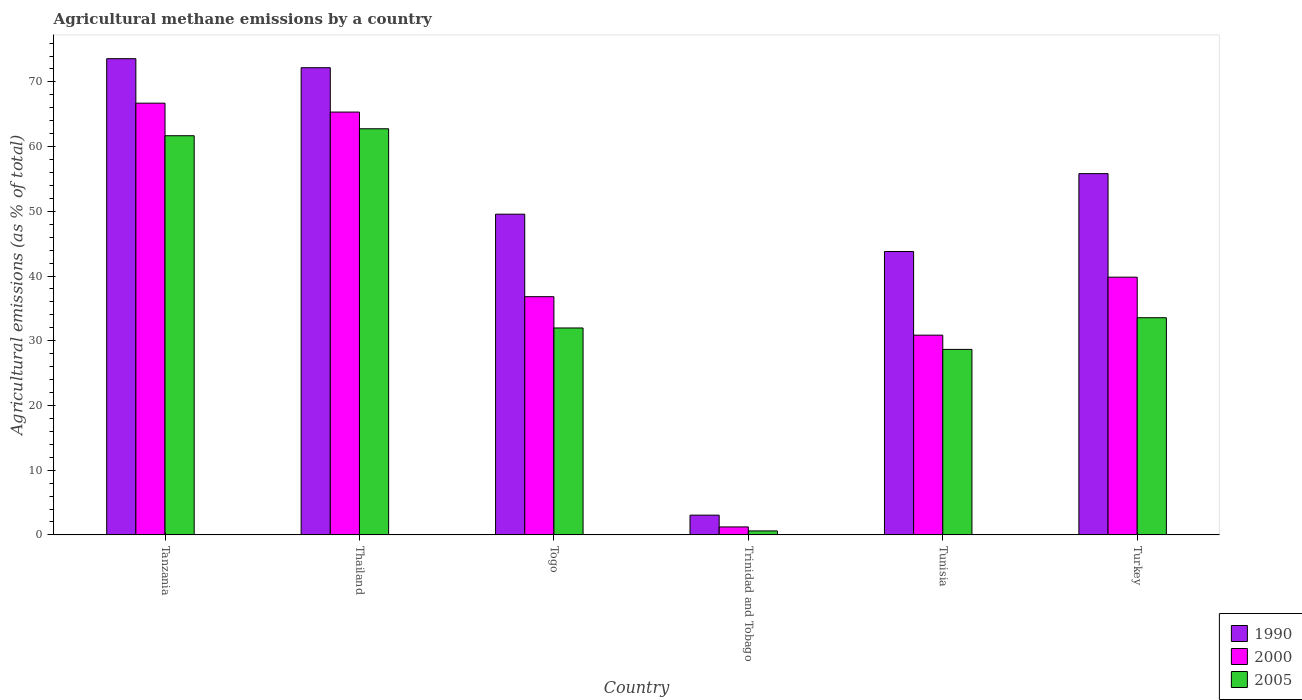How many different coloured bars are there?
Your response must be concise. 3. How many groups of bars are there?
Ensure brevity in your answer.  6. Are the number of bars on each tick of the X-axis equal?
Keep it short and to the point. Yes. What is the label of the 3rd group of bars from the left?
Your answer should be very brief. Togo. In how many cases, is the number of bars for a given country not equal to the number of legend labels?
Offer a very short reply. 0. What is the amount of agricultural methane emitted in 2005 in Turkey?
Provide a succinct answer. 33.56. Across all countries, what is the maximum amount of agricultural methane emitted in 2000?
Your answer should be compact. 66.72. Across all countries, what is the minimum amount of agricultural methane emitted in 1990?
Your response must be concise. 3.05. In which country was the amount of agricultural methane emitted in 1990 maximum?
Provide a short and direct response. Tanzania. In which country was the amount of agricultural methane emitted in 1990 minimum?
Provide a succinct answer. Trinidad and Tobago. What is the total amount of agricultural methane emitted in 2000 in the graph?
Make the answer very short. 240.79. What is the difference between the amount of agricultural methane emitted in 2005 in Tunisia and that in Turkey?
Provide a succinct answer. -4.9. What is the difference between the amount of agricultural methane emitted in 2000 in Tunisia and the amount of agricultural methane emitted in 1990 in Trinidad and Tobago?
Provide a succinct answer. 27.81. What is the average amount of agricultural methane emitted in 1990 per country?
Keep it short and to the point. 49.67. What is the difference between the amount of agricultural methane emitted of/in 1990 and amount of agricultural methane emitted of/in 2005 in Togo?
Ensure brevity in your answer.  17.58. In how many countries, is the amount of agricultural methane emitted in 1990 greater than 42 %?
Give a very brief answer. 5. What is the ratio of the amount of agricultural methane emitted in 2005 in Tanzania to that in Togo?
Your answer should be very brief. 1.93. What is the difference between the highest and the second highest amount of agricultural methane emitted in 2005?
Your response must be concise. -28.12. What is the difference between the highest and the lowest amount of agricultural methane emitted in 2000?
Ensure brevity in your answer.  65.49. In how many countries, is the amount of agricultural methane emitted in 2000 greater than the average amount of agricultural methane emitted in 2000 taken over all countries?
Your answer should be compact. 2. What does the 3rd bar from the left in Tunisia represents?
Offer a terse response. 2005. Is it the case that in every country, the sum of the amount of agricultural methane emitted in 1990 and amount of agricultural methane emitted in 2005 is greater than the amount of agricultural methane emitted in 2000?
Your response must be concise. Yes. How many bars are there?
Your answer should be compact. 18. What is the difference between two consecutive major ticks on the Y-axis?
Ensure brevity in your answer.  10. Are the values on the major ticks of Y-axis written in scientific E-notation?
Your response must be concise. No. Does the graph contain any zero values?
Your answer should be compact. No. Where does the legend appear in the graph?
Your answer should be compact. Bottom right. How are the legend labels stacked?
Provide a succinct answer. Vertical. What is the title of the graph?
Ensure brevity in your answer.  Agricultural methane emissions by a country. What is the label or title of the Y-axis?
Make the answer very short. Agricultural emissions (as % of total). What is the Agricultural emissions (as % of total) in 1990 in Tanzania?
Ensure brevity in your answer.  73.59. What is the Agricultural emissions (as % of total) in 2000 in Tanzania?
Offer a terse response. 66.72. What is the Agricultural emissions (as % of total) in 2005 in Tanzania?
Offer a very short reply. 61.68. What is the Agricultural emissions (as % of total) of 1990 in Thailand?
Provide a short and direct response. 72.19. What is the Agricultural emissions (as % of total) of 2000 in Thailand?
Your answer should be very brief. 65.34. What is the Agricultural emissions (as % of total) of 2005 in Thailand?
Make the answer very short. 62.76. What is the Agricultural emissions (as % of total) of 1990 in Togo?
Offer a terse response. 49.56. What is the Agricultural emissions (as % of total) in 2000 in Togo?
Offer a very short reply. 36.81. What is the Agricultural emissions (as % of total) of 2005 in Togo?
Provide a succinct answer. 31.98. What is the Agricultural emissions (as % of total) of 1990 in Trinidad and Tobago?
Your answer should be compact. 3.05. What is the Agricultural emissions (as % of total) in 2000 in Trinidad and Tobago?
Make the answer very short. 1.23. What is the Agricultural emissions (as % of total) of 2005 in Trinidad and Tobago?
Ensure brevity in your answer.  0.62. What is the Agricultural emissions (as % of total) in 1990 in Tunisia?
Make the answer very short. 43.79. What is the Agricultural emissions (as % of total) of 2000 in Tunisia?
Provide a succinct answer. 30.87. What is the Agricultural emissions (as % of total) in 2005 in Tunisia?
Ensure brevity in your answer.  28.66. What is the Agricultural emissions (as % of total) of 1990 in Turkey?
Offer a terse response. 55.83. What is the Agricultural emissions (as % of total) of 2000 in Turkey?
Give a very brief answer. 39.83. What is the Agricultural emissions (as % of total) in 2005 in Turkey?
Your answer should be very brief. 33.56. Across all countries, what is the maximum Agricultural emissions (as % of total) of 1990?
Provide a short and direct response. 73.59. Across all countries, what is the maximum Agricultural emissions (as % of total) of 2000?
Your answer should be very brief. 66.72. Across all countries, what is the maximum Agricultural emissions (as % of total) of 2005?
Your response must be concise. 62.76. Across all countries, what is the minimum Agricultural emissions (as % of total) of 1990?
Offer a terse response. 3.05. Across all countries, what is the minimum Agricultural emissions (as % of total) of 2000?
Ensure brevity in your answer.  1.23. Across all countries, what is the minimum Agricultural emissions (as % of total) of 2005?
Give a very brief answer. 0.62. What is the total Agricultural emissions (as % of total) of 1990 in the graph?
Ensure brevity in your answer.  298.01. What is the total Agricultural emissions (as % of total) of 2000 in the graph?
Your answer should be compact. 240.79. What is the total Agricultural emissions (as % of total) of 2005 in the graph?
Provide a short and direct response. 219.26. What is the difference between the Agricultural emissions (as % of total) of 1990 in Tanzania and that in Thailand?
Ensure brevity in your answer.  1.39. What is the difference between the Agricultural emissions (as % of total) of 2000 in Tanzania and that in Thailand?
Make the answer very short. 1.38. What is the difference between the Agricultural emissions (as % of total) in 2005 in Tanzania and that in Thailand?
Provide a short and direct response. -1.08. What is the difference between the Agricultural emissions (as % of total) in 1990 in Tanzania and that in Togo?
Your answer should be compact. 24.03. What is the difference between the Agricultural emissions (as % of total) of 2000 in Tanzania and that in Togo?
Make the answer very short. 29.9. What is the difference between the Agricultural emissions (as % of total) in 2005 in Tanzania and that in Togo?
Offer a terse response. 29.71. What is the difference between the Agricultural emissions (as % of total) in 1990 in Tanzania and that in Trinidad and Tobago?
Make the answer very short. 70.54. What is the difference between the Agricultural emissions (as % of total) of 2000 in Tanzania and that in Trinidad and Tobago?
Make the answer very short. 65.49. What is the difference between the Agricultural emissions (as % of total) in 2005 in Tanzania and that in Trinidad and Tobago?
Give a very brief answer. 61.07. What is the difference between the Agricultural emissions (as % of total) in 1990 in Tanzania and that in Tunisia?
Offer a very short reply. 29.8. What is the difference between the Agricultural emissions (as % of total) in 2000 in Tanzania and that in Tunisia?
Your response must be concise. 35.85. What is the difference between the Agricultural emissions (as % of total) of 2005 in Tanzania and that in Tunisia?
Your answer should be compact. 33.02. What is the difference between the Agricultural emissions (as % of total) in 1990 in Tanzania and that in Turkey?
Give a very brief answer. 17.76. What is the difference between the Agricultural emissions (as % of total) of 2000 in Tanzania and that in Turkey?
Your answer should be compact. 26.89. What is the difference between the Agricultural emissions (as % of total) of 2005 in Tanzania and that in Turkey?
Ensure brevity in your answer.  28.12. What is the difference between the Agricultural emissions (as % of total) of 1990 in Thailand and that in Togo?
Ensure brevity in your answer.  22.63. What is the difference between the Agricultural emissions (as % of total) in 2000 in Thailand and that in Togo?
Your answer should be very brief. 28.53. What is the difference between the Agricultural emissions (as % of total) of 2005 in Thailand and that in Togo?
Make the answer very short. 30.78. What is the difference between the Agricultural emissions (as % of total) in 1990 in Thailand and that in Trinidad and Tobago?
Make the answer very short. 69.14. What is the difference between the Agricultural emissions (as % of total) of 2000 in Thailand and that in Trinidad and Tobago?
Your response must be concise. 64.11. What is the difference between the Agricultural emissions (as % of total) in 2005 in Thailand and that in Trinidad and Tobago?
Offer a very short reply. 62.14. What is the difference between the Agricultural emissions (as % of total) in 1990 in Thailand and that in Tunisia?
Make the answer very short. 28.4. What is the difference between the Agricultural emissions (as % of total) of 2000 in Thailand and that in Tunisia?
Your response must be concise. 34.47. What is the difference between the Agricultural emissions (as % of total) of 2005 in Thailand and that in Tunisia?
Give a very brief answer. 34.09. What is the difference between the Agricultural emissions (as % of total) of 1990 in Thailand and that in Turkey?
Offer a very short reply. 16.37. What is the difference between the Agricultural emissions (as % of total) of 2000 in Thailand and that in Turkey?
Offer a terse response. 25.51. What is the difference between the Agricultural emissions (as % of total) in 2005 in Thailand and that in Turkey?
Give a very brief answer. 29.2. What is the difference between the Agricultural emissions (as % of total) of 1990 in Togo and that in Trinidad and Tobago?
Your answer should be compact. 46.51. What is the difference between the Agricultural emissions (as % of total) in 2000 in Togo and that in Trinidad and Tobago?
Ensure brevity in your answer.  35.58. What is the difference between the Agricultural emissions (as % of total) of 2005 in Togo and that in Trinidad and Tobago?
Offer a terse response. 31.36. What is the difference between the Agricultural emissions (as % of total) of 1990 in Togo and that in Tunisia?
Make the answer very short. 5.77. What is the difference between the Agricultural emissions (as % of total) in 2000 in Togo and that in Tunisia?
Ensure brevity in your answer.  5.95. What is the difference between the Agricultural emissions (as % of total) in 2005 in Togo and that in Tunisia?
Make the answer very short. 3.31. What is the difference between the Agricultural emissions (as % of total) in 1990 in Togo and that in Turkey?
Your answer should be very brief. -6.27. What is the difference between the Agricultural emissions (as % of total) in 2000 in Togo and that in Turkey?
Your answer should be compact. -3.01. What is the difference between the Agricultural emissions (as % of total) in 2005 in Togo and that in Turkey?
Ensure brevity in your answer.  -1.58. What is the difference between the Agricultural emissions (as % of total) in 1990 in Trinidad and Tobago and that in Tunisia?
Keep it short and to the point. -40.74. What is the difference between the Agricultural emissions (as % of total) of 2000 in Trinidad and Tobago and that in Tunisia?
Give a very brief answer. -29.64. What is the difference between the Agricultural emissions (as % of total) in 2005 in Trinidad and Tobago and that in Tunisia?
Your answer should be very brief. -28.05. What is the difference between the Agricultural emissions (as % of total) of 1990 in Trinidad and Tobago and that in Turkey?
Ensure brevity in your answer.  -52.78. What is the difference between the Agricultural emissions (as % of total) in 2000 in Trinidad and Tobago and that in Turkey?
Keep it short and to the point. -38.6. What is the difference between the Agricultural emissions (as % of total) of 2005 in Trinidad and Tobago and that in Turkey?
Offer a terse response. -32.94. What is the difference between the Agricultural emissions (as % of total) of 1990 in Tunisia and that in Turkey?
Offer a terse response. -12.03. What is the difference between the Agricultural emissions (as % of total) in 2000 in Tunisia and that in Turkey?
Make the answer very short. -8.96. What is the difference between the Agricultural emissions (as % of total) of 2005 in Tunisia and that in Turkey?
Your answer should be very brief. -4.9. What is the difference between the Agricultural emissions (as % of total) in 1990 in Tanzania and the Agricultural emissions (as % of total) in 2000 in Thailand?
Give a very brief answer. 8.25. What is the difference between the Agricultural emissions (as % of total) of 1990 in Tanzania and the Agricultural emissions (as % of total) of 2005 in Thailand?
Provide a succinct answer. 10.83. What is the difference between the Agricultural emissions (as % of total) of 2000 in Tanzania and the Agricultural emissions (as % of total) of 2005 in Thailand?
Offer a terse response. 3.96. What is the difference between the Agricultural emissions (as % of total) in 1990 in Tanzania and the Agricultural emissions (as % of total) in 2000 in Togo?
Your answer should be very brief. 36.78. What is the difference between the Agricultural emissions (as % of total) of 1990 in Tanzania and the Agricultural emissions (as % of total) of 2005 in Togo?
Offer a very short reply. 41.61. What is the difference between the Agricultural emissions (as % of total) of 2000 in Tanzania and the Agricultural emissions (as % of total) of 2005 in Togo?
Your answer should be compact. 34.74. What is the difference between the Agricultural emissions (as % of total) in 1990 in Tanzania and the Agricultural emissions (as % of total) in 2000 in Trinidad and Tobago?
Your answer should be compact. 72.36. What is the difference between the Agricultural emissions (as % of total) in 1990 in Tanzania and the Agricultural emissions (as % of total) in 2005 in Trinidad and Tobago?
Your response must be concise. 72.97. What is the difference between the Agricultural emissions (as % of total) in 2000 in Tanzania and the Agricultural emissions (as % of total) in 2005 in Trinidad and Tobago?
Give a very brief answer. 66.1. What is the difference between the Agricultural emissions (as % of total) of 1990 in Tanzania and the Agricultural emissions (as % of total) of 2000 in Tunisia?
Your answer should be compact. 42.72. What is the difference between the Agricultural emissions (as % of total) of 1990 in Tanzania and the Agricultural emissions (as % of total) of 2005 in Tunisia?
Give a very brief answer. 44.93. What is the difference between the Agricultural emissions (as % of total) in 2000 in Tanzania and the Agricultural emissions (as % of total) in 2005 in Tunisia?
Your answer should be compact. 38.05. What is the difference between the Agricultural emissions (as % of total) of 1990 in Tanzania and the Agricultural emissions (as % of total) of 2000 in Turkey?
Your answer should be compact. 33.76. What is the difference between the Agricultural emissions (as % of total) of 1990 in Tanzania and the Agricultural emissions (as % of total) of 2005 in Turkey?
Your answer should be very brief. 40.03. What is the difference between the Agricultural emissions (as % of total) in 2000 in Tanzania and the Agricultural emissions (as % of total) in 2005 in Turkey?
Give a very brief answer. 33.16. What is the difference between the Agricultural emissions (as % of total) of 1990 in Thailand and the Agricultural emissions (as % of total) of 2000 in Togo?
Provide a short and direct response. 35.38. What is the difference between the Agricultural emissions (as % of total) of 1990 in Thailand and the Agricultural emissions (as % of total) of 2005 in Togo?
Make the answer very short. 40.22. What is the difference between the Agricultural emissions (as % of total) in 2000 in Thailand and the Agricultural emissions (as % of total) in 2005 in Togo?
Ensure brevity in your answer.  33.36. What is the difference between the Agricultural emissions (as % of total) of 1990 in Thailand and the Agricultural emissions (as % of total) of 2000 in Trinidad and Tobago?
Ensure brevity in your answer.  70.96. What is the difference between the Agricultural emissions (as % of total) in 1990 in Thailand and the Agricultural emissions (as % of total) in 2005 in Trinidad and Tobago?
Offer a terse response. 71.58. What is the difference between the Agricultural emissions (as % of total) of 2000 in Thailand and the Agricultural emissions (as % of total) of 2005 in Trinidad and Tobago?
Offer a very short reply. 64.72. What is the difference between the Agricultural emissions (as % of total) of 1990 in Thailand and the Agricultural emissions (as % of total) of 2000 in Tunisia?
Your answer should be very brief. 41.33. What is the difference between the Agricultural emissions (as % of total) in 1990 in Thailand and the Agricultural emissions (as % of total) in 2005 in Tunisia?
Your response must be concise. 43.53. What is the difference between the Agricultural emissions (as % of total) of 2000 in Thailand and the Agricultural emissions (as % of total) of 2005 in Tunisia?
Ensure brevity in your answer.  36.68. What is the difference between the Agricultural emissions (as % of total) in 1990 in Thailand and the Agricultural emissions (as % of total) in 2000 in Turkey?
Keep it short and to the point. 32.37. What is the difference between the Agricultural emissions (as % of total) in 1990 in Thailand and the Agricultural emissions (as % of total) in 2005 in Turkey?
Your response must be concise. 38.64. What is the difference between the Agricultural emissions (as % of total) of 2000 in Thailand and the Agricultural emissions (as % of total) of 2005 in Turkey?
Keep it short and to the point. 31.78. What is the difference between the Agricultural emissions (as % of total) in 1990 in Togo and the Agricultural emissions (as % of total) in 2000 in Trinidad and Tobago?
Give a very brief answer. 48.33. What is the difference between the Agricultural emissions (as % of total) of 1990 in Togo and the Agricultural emissions (as % of total) of 2005 in Trinidad and Tobago?
Keep it short and to the point. 48.94. What is the difference between the Agricultural emissions (as % of total) in 2000 in Togo and the Agricultural emissions (as % of total) in 2005 in Trinidad and Tobago?
Keep it short and to the point. 36.2. What is the difference between the Agricultural emissions (as % of total) in 1990 in Togo and the Agricultural emissions (as % of total) in 2000 in Tunisia?
Your answer should be compact. 18.69. What is the difference between the Agricultural emissions (as % of total) of 1990 in Togo and the Agricultural emissions (as % of total) of 2005 in Tunisia?
Give a very brief answer. 20.9. What is the difference between the Agricultural emissions (as % of total) of 2000 in Togo and the Agricultural emissions (as % of total) of 2005 in Tunisia?
Your answer should be compact. 8.15. What is the difference between the Agricultural emissions (as % of total) in 1990 in Togo and the Agricultural emissions (as % of total) in 2000 in Turkey?
Keep it short and to the point. 9.73. What is the difference between the Agricultural emissions (as % of total) of 1990 in Togo and the Agricultural emissions (as % of total) of 2005 in Turkey?
Your response must be concise. 16. What is the difference between the Agricultural emissions (as % of total) in 2000 in Togo and the Agricultural emissions (as % of total) in 2005 in Turkey?
Offer a very short reply. 3.25. What is the difference between the Agricultural emissions (as % of total) in 1990 in Trinidad and Tobago and the Agricultural emissions (as % of total) in 2000 in Tunisia?
Keep it short and to the point. -27.81. What is the difference between the Agricultural emissions (as % of total) in 1990 in Trinidad and Tobago and the Agricultural emissions (as % of total) in 2005 in Tunisia?
Keep it short and to the point. -25.61. What is the difference between the Agricultural emissions (as % of total) of 2000 in Trinidad and Tobago and the Agricultural emissions (as % of total) of 2005 in Tunisia?
Ensure brevity in your answer.  -27.43. What is the difference between the Agricultural emissions (as % of total) of 1990 in Trinidad and Tobago and the Agricultural emissions (as % of total) of 2000 in Turkey?
Provide a succinct answer. -36.78. What is the difference between the Agricultural emissions (as % of total) of 1990 in Trinidad and Tobago and the Agricultural emissions (as % of total) of 2005 in Turkey?
Your answer should be compact. -30.51. What is the difference between the Agricultural emissions (as % of total) in 2000 in Trinidad and Tobago and the Agricultural emissions (as % of total) in 2005 in Turkey?
Offer a very short reply. -32.33. What is the difference between the Agricultural emissions (as % of total) of 1990 in Tunisia and the Agricultural emissions (as % of total) of 2000 in Turkey?
Offer a terse response. 3.97. What is the difference between the Agricultural emissions (as % of total) of 1990 in Tunisia and the Agricultural emissions (as % of total) of 2005 in Turkey?
Provide a short and direct response. 10.23. What is the difference between the Agricultural emissions (as % of total) in 2000 in Tunisia and the Agricultural emissions (as % of total) in 2005 in Turkey?
Your response must be concise. -2.69. What is the average Agricultural emissions (as % of total) in 1990 per country?
Keep it short and to the point. 49.67. What is the average Agricultural emissions (as % of total) of 2000 per country?
Ensure brevity in your answer.  40.13. What is the average Agricultural emissions (as % of total) of 2005 per country?
Offer a terse response. 36.54. What is the difference between the Agricultural emissions (as % of total) of 1990 and Agricultural emissions (as % of total) of 2000 in Tanzania?
Your answer should be compact. 6.87. What is the difference between the Agricultural emissions (as % of total) in 1990 and Agricultural emissions (as % of total) in 2005 in Tanzania?
Offer a terse response. 11.91. What is the difference between the Agricultural emissions (as % of total) of 2000 and Agricultural emissions (as % of total) of 2005 in Tanzania?
Offer a terse response. 5.03. What is the difference between the Agricultural emissions (as % of total) of 1990 and Agricultural emissions (as % of total) of 2000 in Thailand?
Ensure brevity in your answer.  6.85. What is the difference between the Agricultural emissions (as % of total) of 1990 and Agricultural emissions (as % of total) of 2005 in Thailand?
Your answer should be very brief. 9.44. What is the difference between the Agricultural emissions (as % of total) in 2000 and Agricultural emissions (as % of total) in 2005 in Thailand?
Provide a short and direct response. 2.58. What is the difference between the Agricultural emissions (as % of total) of 1990 and Agricultural emissions (as % of total) of 2000 in Togo?
Offer a terse response. 12.75. What is the difference between the Agricultural emissions (as % of total) in 1990 and Agricultural emissions (as % of total) in 2005 in Togo?
Keep it short and to the point. 17.58. What is the difference between the Agricultural emissions (as % of total) of 2000 and Agricultural emissions (as % of total) of 2005 in Togo?
Offer a terse response. 4.84. What is the difference between the Agricultural emissions (as % of total) of 1990 and Agricultural emissions (as % of total) of 2000 in Trinidad and Tobago?
Offer a very short reply. 1.82. What is the difference between the Agricultural emissions (as % of total) of 1990 and Agricultural emissions (as % of total) of 2005 in Trinidad and Tobago?
Keep it short and to the point. 2.44. What is the difference between the Agricultural emissions (as % of total) of 2000 and Agricultural emissions (as % of total) of 2005 in Trinidad and Tobago?
Ensure brevity in your answer.  0.61. What is the difference between the Agricultural emissions (as % of total) of 1990 and Agricultural emissions (as % of total) of 2000 in Tunisia?
Your response must be concise. 12.93. What is the difference between the Agricultural emissions (as % of total) in 1990 and Agricultural emissions (as % of total) in 2005 in Tunisia?
Your response must be concise. 15.13. What is the difference between the Agricultural emissions (as % of total) of 2000 and Agricultural emissions (as % of total) of 2005 in Tunisia?
Your answer should be very brief. 2.2. What is the difference between the Agricultural emissions (as % of total) of 1990 and Agricultural emissions (as % of total) of 2000 in Turkey?
Your answer should be compact. 16. What is the difference between the Agricultural emissions (as % of total) in 1990 and Agricultural emissions (as % of total) in 2005 in Turkey?
Your answer should be very brief. 22.27. What is the difference between the Agricultural emissions (as % of total) of 2000 and Agricultural emissions (as % of total) of 2005 in Turkey?
Give a very brief answer. 6.27. What is the ratio of the Agricultural emissions (as % of total) of 1990 in Tanzania to that in Thailand?
Ensure brevity in your answer.  1.02. What is the ratio of the Agricultural emissions (as % of total) in 2000 in Tanzania to that in Thailand?
Make the answer very short. 1.02. What is the ratio of the Agricultural emissions (as % of total) of 2005 in Tanzania to that in Thailand?
Offer a very short reply. 0.98. What is the ratio of the Agricultural emissions (as % of total) of 1990 in Tanzania to that in Togo?
Keep it short and to the point. 1.48. What is the ratio of the Agricultural emissions (as % of total) of 2000 in Tanzania to that in Togo?
Provide a short and direct response. 1.81. What is the ratio of the Agricultural emissions (as % of total) in 2005 in Tanzania to that in Togo?
Ensure brevity in your answer.  1.93. What is the ratio of the Agricultural emissions (as % of total) of 1990 in Tanzania to that in Trinidad and Tobago?
Your response must be concise. 24.11. What is the ratio of the Agricultural emissions (as % of total) in 2000 in Tanzania to that in Trinidad and Tobago?
Your response must be concise. 54.23. What is the ratio of the Agricultural emissions (as % of total) in 2005 in Tanzania to that in Trinidad and Tobago?
Give a very brief answer. 100.13. What is the ratio of the Agricultural emissions (as % of total) in 1990 in Tanzania to that in Tunisia?
Ensure brevity in your answer.  1.68. What is the ratio of the Agricultural emissions (as % of total) in 2000 in Tanzania to that in Tunisia?
Your answer should be very brief. 2.16. What is the ratio of the Agricultural emissions (as % of total) in 2005 in Tanzania to that in Tunisia?
Give a very brief answer. 2.15. What is the ratio of the Agricultural emissions (as % of total) in 1990 in Tanzania to that in Turkey?
Your response must be concise. 1.32. What is the ratio of the Agricultural emissions (as % of total) in 2000 in Tanzania to that in Turkey?
Give a very brief answer. 1.68. What is the ratio of the Agricultural emissions (as % of total) of 2005 in Tanzania to that in Turkey?
Provide a succinct answer. 1.84. What is the ratio of the Agricultural emissions (as % of total) in 1990 in Thailand to that in Togo?
Provide a short and direct response. 1.46. What is the ratio of the Agricultural emissions (as % of total) in 2000 in Thailand to that in Togo?
Offer a terse response. 1.77. What is the ratio of the Agricultural emissions (as % of total) in 2005 in Thailand to that in Togo?
Your answer should be compact. 1.96. What is the ratio of the Agricultural emissions (as % of total) of 1990 in Thailand to that in Trinidad and Tobago?
Offer a terse response. 23.66. What is the ratio of the Agricultural emissions (as % of total) of 2000 in Thailand to that in Trinidad and Tobago?
Your answer should be very brief. 53.11. What is the ratio of the Agricultural emissions (as % of total) of 2005 in Thailand to that in Trinidad and Tobago?
Give a very brief answer. 101.88. What is the ratio of the Agricultural emissions (as % of total) of 1990 in Thailand to that in Tunisia?
Your answer should be compact. 1.65. What is the ratio of the Agricultural emissions (as % of total) in 2000 in Thailand to that in Tunisia?
Your response must be concise. 2.12. What is the ratio of the Agricultural emissions (as % of total) of 2005 in Thailand to that in Tunisia?
Your answer should be very brief. 2.19. What is the ratio of the Agricultural emissions (as % of total) in 1990 in Thailand to that in Turkey?
Offer a very short reply. 1.29. What is the ratio of the Agricultural emissions (as % of total) of 2000 in Thailand to that in Turkey?
Offer a terse response. 1.64. What is the ratio of the Agricultural emissions (as % of total) of 2005 in Thailand to that in Turkey?
Offer a terse response. 1.87. What is the ratio of the Agricultural emissions (as % of total) of 1990 in Togo to that in Trinidad and Tobago?
Ensure brevity in your answer.  16.24. What is the ratio of the Agricultural emissions (as % of total) in 2000 in Togo to that in Trinidad and Tobago?
Make the answer very short. 29.92. What is the ratio of the Agricultural emissions (as % of total) of 2005 in Togo to that in Trinidad and Tobago?
Give a very brief answer. 51.91. What is the ratio of the Agricultural emissions (as % of total) in 1990 in Togo to that in Tunisia?
Ensure brevity in your answer.  1.13. What is the ratio of the Agricultural emissions (as % of total) of 2000 in Togo to that in Tunisia?
Your response must be concise. 1.19. What is the ratio of the Agricultural emissions (as % of total) in 2005 in Togo to that in Tunisia?
Ensure brevity in your answer.  1.12. What is the ratio of the Agricultural emissions (as % of total) of 1990 in Togo to that in Turkey?
Keep it short and to the point. 0.89. What is the ratio of the Agricultural emissions (as % of total) of 2000 in Togo to that in Turkey?
Make the answer very short. 0.92. What is the ratio of the Agricultural emissions (as % of total) in 2005 in Togo to that in Turkey?
Give a very brief answer. 0.95. What is the ratio of the Agricultural emissions (as % of total) of 1990 in Trinidad and Tobago to that in Tunisia?
Ensure brevity in your answer.  0.07. What is the ratio of the Agricultural emissions (as % of total) of 2000 in Trinidad and Tobago to that in Tunisia?
Keep it short and to the point. 0.04. What is the ratio of the Agricultural emissions (as % of total) in 2005 in Trinidad and Tobago to that in Tunisia?
Your response must be concise. 0.02. What is the ratio of the Agricultural emissions (as % of total) of 1990 in Trinidad and Tobago to that in Turkey?
Your response must be concise. 0.05. What is the ratio of the Agricultural emissions (as % of total) in 2000 in Trinidad and Tobago to that in Turkey?
Your response must be concise. 0.03. What is the ratio of the Agricultural emissions (as % of total) of 2005 in Trinidad and Tobago to that in Turkey?
Give a very brief answer. 0.02. What is the ratio of the Agricultural emissions (as % of total) of 1990 in Tunisia to that in Turkey?
Provide a succinct answer. 0.78. What is the ratio of the Agricultural emissions (as % of total) in 2000 in Tunisia to that in Turkey?
Provide a succinct answer. 0.78. What is the ratio of the Agricultural emissions (as % of total) in 2005 in Tunisia to that in Turkey?
Provide a short and direct response. 0.85. What is the difference between the highest and the second highest Agricultural emissions (as % of total) of 1990?
Provide a succinct answer. 1.39. What is the difference between the highest and the second highest Agricultural emissions (as % of total) in 2000?
Provide a short and direct response. 1.38. What is the difference between the highest and the second highest Agricultural emissions (as % of total) of 2005?
Your response must be concise. 1.08. What is the difference between the highest and the lowest Agricultural emissions (as % of total) in 1990?
Provide a short and direct response. 70.54. What is the difference between the highest and the lowest Agricultural emissions (as % of total) of 2000?
Ensure brevity in your answer.  65.49. What is the difference between the highest and the lowest Agricultural emissions (as % of total) of 2005?
Offer a terse response. 62.14. 